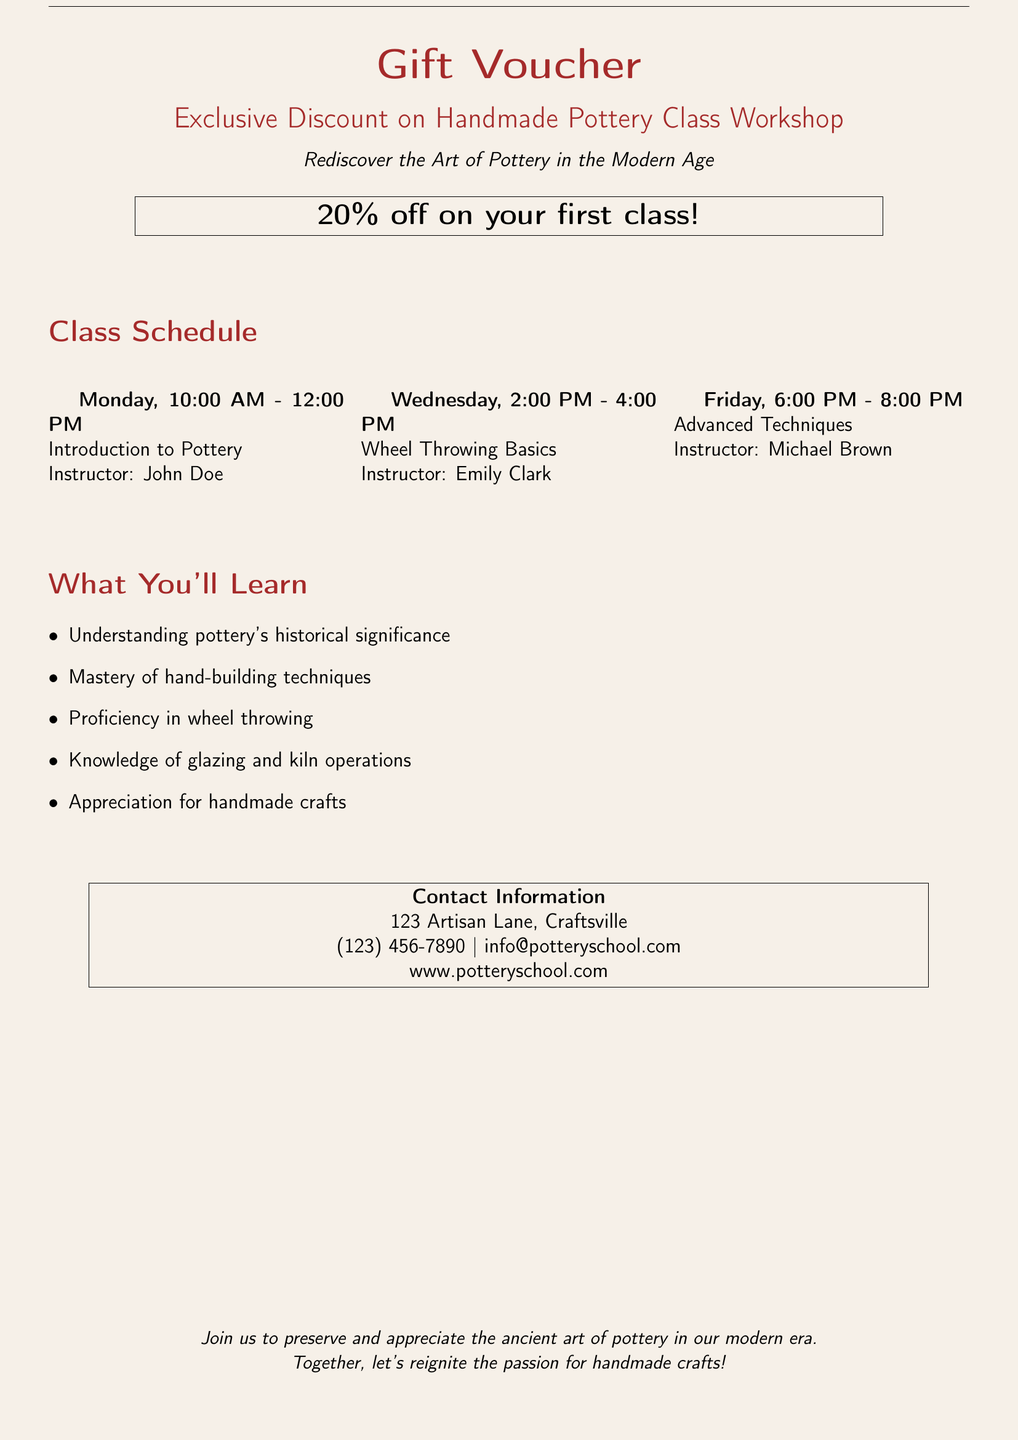What is the discount offered? The document states that there is a 20% discount on the first class.
Answer: 20% off Who is the instructor for the Wheel Throwing Basics class? The document lists the instructors for each class, and Emily Clark teaches Wheel Throwing Basics.
Answer: Emily Clark What day and time is Advanced Techniques class scheduled? The class schedule provides the specific day and time for each class, indicating that Advanced Techniques is on Friday from 6:00 PM to 8:00 PM.
Answer: Friday, 6:00 PM - 8:00 PM What will students learn about glazing? The document outlines the learning objectives, indicating that students will gain knowledge of glazing and kiln operations.
Answer: Knowledge of glazing How many classes are scheduled in the week? The class schedule shows three classes that are held each week.
Answer: Three classes What is the title of the voucher? The document promotes a specific offer with a title that introduces the exclusive discount on the pottery workshop.
Answer: Exclusive Discount on Handmade Pottery Class Workshop Where can you find the contact information? The document provides a designated section at the bottom for contact details, including address, phone number, and email.
Answer: Contact Information What is the purpose of the workshop according to the document? The document's introduction highlights its goal to help uncover the art of pottery in the modern age.
Answer: Rediscover the Art of Pottery in the Modern Age What is the address of the pottery school? The contact information section includes the physical address of the pottery school.
Answer: 123 Artisan Lane, Craftsville 